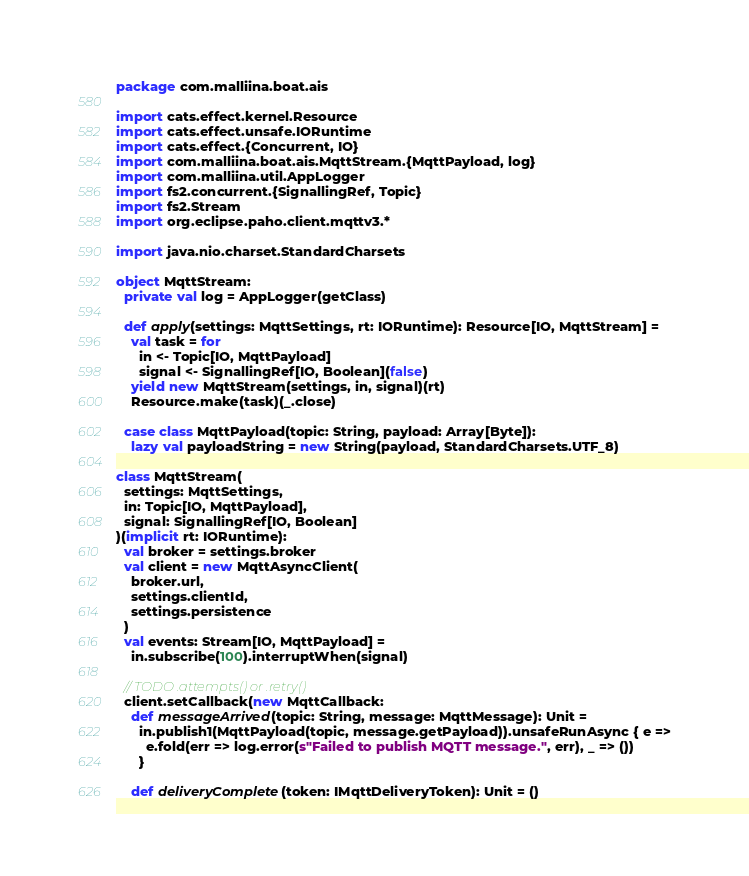Convert code to text. <code><loc_0><loc_0><loc_500><loc_500><_Scala_>package com.malliina.boat.ais

import cats.effect.kernel.Resource
import cats.effect.unsafe.IORuntime
import cats.effect.{Concurrent, IO}
import com.malliina.boat.ais.MqttStream.{MqttPayload, log}
import com.malliina.util.AppLogger
import fs2.concurrent.{SignallingRef, Topic}
import fs2.Stream
import org.eclipse.paho.client.mqttv3.*

import java.nio.charset.StandardCharsets

object MqttStream:
  private val log = AppLogger(getClass)

  def apply(settings: MqttSettings, rt: IORuntime): Resource[IO, MqttStream] =
    val task = for
      in <- Topic[IO, MqttPayload]
      signal <- SignallingRef[IO, Boolean](false)
    yield new MqttStream(settings, in, signal)(rt)
    Resource.make(task)(_.close)

  case class MqttPayload(topic: String, payload: Array[Byte]):
    lazy val payloadString = new String(payload, StandardCharsets.UTF_8)

class MqttStream(
  settings: MqttSettings,
  in: Topic[IO, MqttPayload],
  signal: SignallingRef[IO, Boolean]
)(implicit rt: IORuntime):
  val broker = settings.broker
  val client = new MqttAsyncClient(
    broker.url,
    settings.clientId,
    settings.persistence
  )
  val events: Stream[IO, MqttPayload] =
    in.subscribe(100).interruptWhen(signal)

  // TODO .attempts() or .retry()
  client.setCallback(new MqttCallback:
    def messageArrived(topic: String, message: MqttMessage): Unit =
      in.publish1(MqttPayload(topic, message.getPayload)).unsafeRunAsync { e =>
        e.fold(err => log.error(s"Failed to publish MQTT message.", err), _ => ())
      }

    def deliveryComplete(token: IMqttDeliveryToken): Unit = ()
</code> 